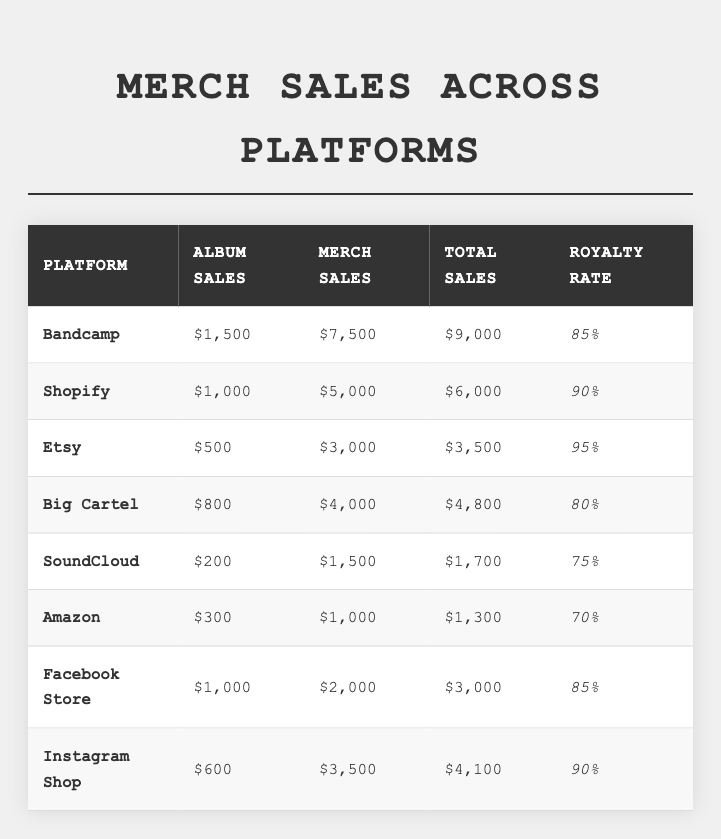What platform has the highest total sales? Looking at the "Total Sales" column, Bandcamp has the highest amount at $9,000 compared to other platforms.
Answer: Bandcamp Which platform has the lowest royalty rate? The "Royalty Rate" column indicates that Amazon has the lowest royalty rate of 70%.
Answer: Amazon What is the total merchandise sales for Shopify? The "Merch Sales" column shows Shopify's merchandise sales are $5,000.
Answer: $5,000 How much more did Bandcamp sell in merch compared to SoundCloud? Bandcamp's merch sales are $7,500, and SoundCloud's are $1,500. The difference is $7,500 - $1,500 = $6,000.
Answer: $6,000 Which platform has a total sales amount below $4,000? Examining the "Total Sales" column, the platforms below $4,000 are SoundCloud at $1,700 and Amazon at $1,300.
Answer: SoundCloud and Amazon What is the average royalty rate for all platforms? To find the average, sum up the royalty rates (85 + 90 + 95 + 80 + 75 + 70 + 85 + 90 =  665) and divide by the number of platforms (8). Thus, the average is 665 / 8 = 83.125%.
Answer: 83.125% Did Instagram Shop have more album sales than Etsy? Instagram Shop had 600 album sales while Etsy had 500. Thus, Instagram Shop had more album sales.
Answer: Yes What is the total combined sales for Facebook Store and Big Cartel? Facebook Store total sales are $3,000 and Big Cartel total sales are $4,800. Adding both gives $3,000 + $4,800 = $7,800.
Answer: $7,800 Is the album sale amount for Amazon greater than the album sale amount for Big Cartel? Amazon has album sales of 300, while Big Cartel has 800. Since 300 is less than 800, Amazon's album sales are not greater.
Answer: No How much total sales does the platform with the second highest total sales have? The platform with the second highest total sales is Shopify at $6,000 total.
Answer: $6,000 